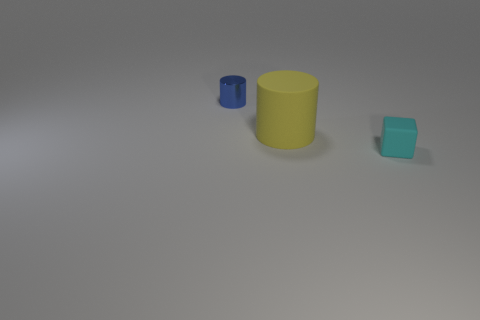Is there anything else that has the same size as the yellow rubber object?
Your answer should be compact. No. How many other objects are the same size as the rubber cylinder?
Offer a terse response. 0. There is a matte object behind the rubber cube; is it the same shape as the tiny object that is left of the big yellow cylinder?
Offer a very short reply. Yes. There is a tiny block; are there any blue metallic cylinders behind it?
Your answer should be compact. Yes. What is the color of the other thing that is the same shape as the tiny blue shiny object?
Ensure brevity in your answer.  Yellow. Is there any other thing that has the same shape as the small cyan thing?
Offer a terse response. No. What is the material of the cylinder that is behind the yellow cylinder?
Your answer should be compact. Metal. The yellow rubber thing that is the same shape as the tiny metal object is what size?
Keep it short and to the point. Large. How many blue things have the same material as the blue cylinder?
Offer a very short reply. 0. How many big matte objects have the same color as the small rubber object?
Your response must be concise. 0. 